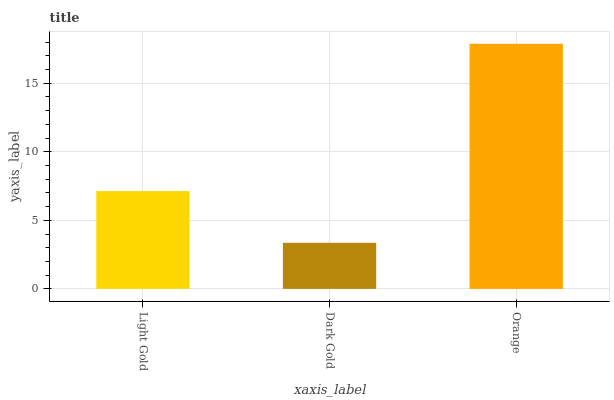Is Orange the minimum?
Answer yes or no. No. Is Dark Gold the maximum?
Answer yes or no. No. Is Orange greater than Dark Gold?
Answer yes or no. Yes. Is Dark Gold less than Orange?
Answer yes or no. Yes. Is Dark Gold greater than Orange?
Answer yes or no. No. Is Orange less than Dark Gold?
Answer yes or no. No. Is Light Gold the high median?
Answer yes or no. Yes. Is Light Gold the low median?
Answer yes or no. Yes. Is Dark Gold the high median?
Answer yes or no. No. Is Dark Gold the low median?
Answer yes or no. No. 